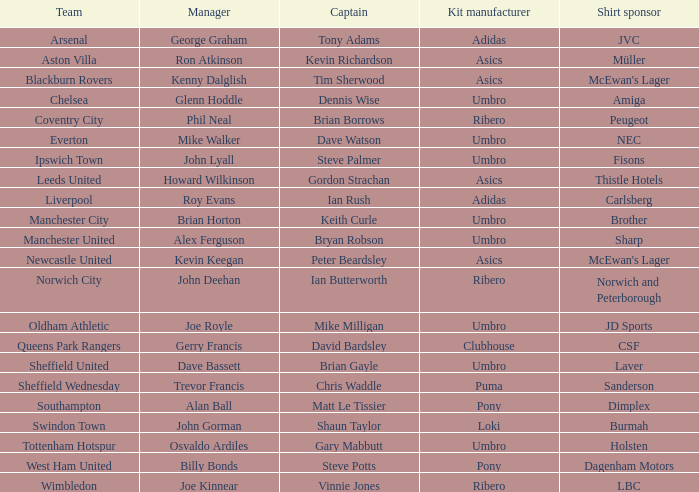On which team does george graham serve as the manager? Arsenal. 